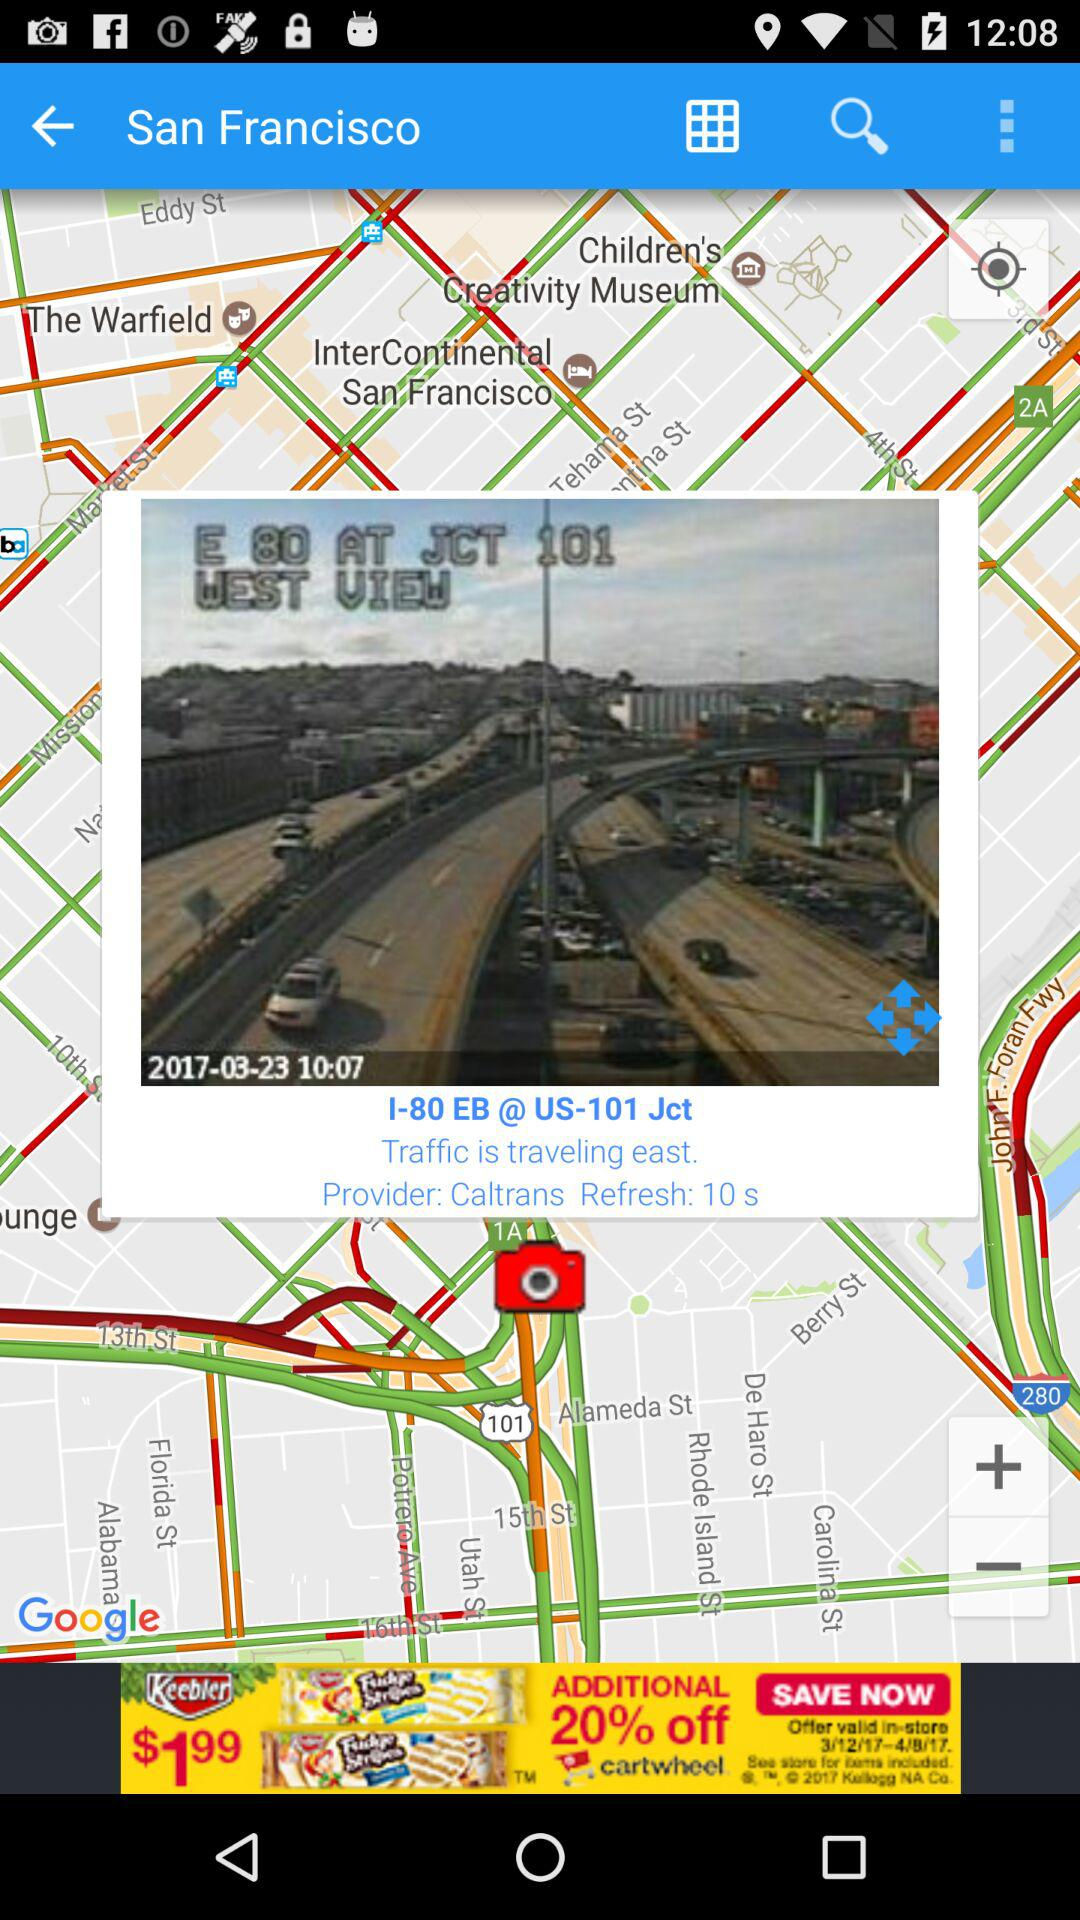What are the time and date that are mentioned? The mentioned time is 10:07 and the date is March 23, 2017. 